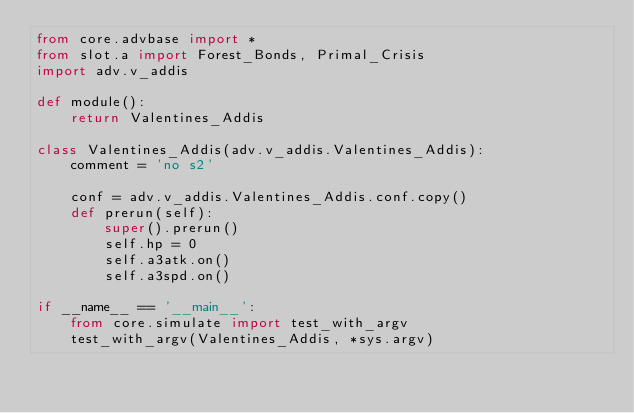<code> <loc_0><loc_0><loc_500><loc_500><_Python_>from core.advbase import *
from slot.a import Forest_Bonds, Primal_Crisis
import adv.v_addis

def module():
    return Valentines_Addis

class Valentines_Addis(adv.v_addis.Valentines_Addis):
    comment = 'no s2'

    conf = adv.v_addis.Valentines_Addis.conf.copy()
    def prerun(self):
        super().prerun()
        self.hp = 0
        self.a3atk.on()
        self.a3spd.on()

if __name__ == '__main__':
    from core.simulate import test_with_argv
    test_with_argv(Valentines_Addis, *sys.argv)</code> 